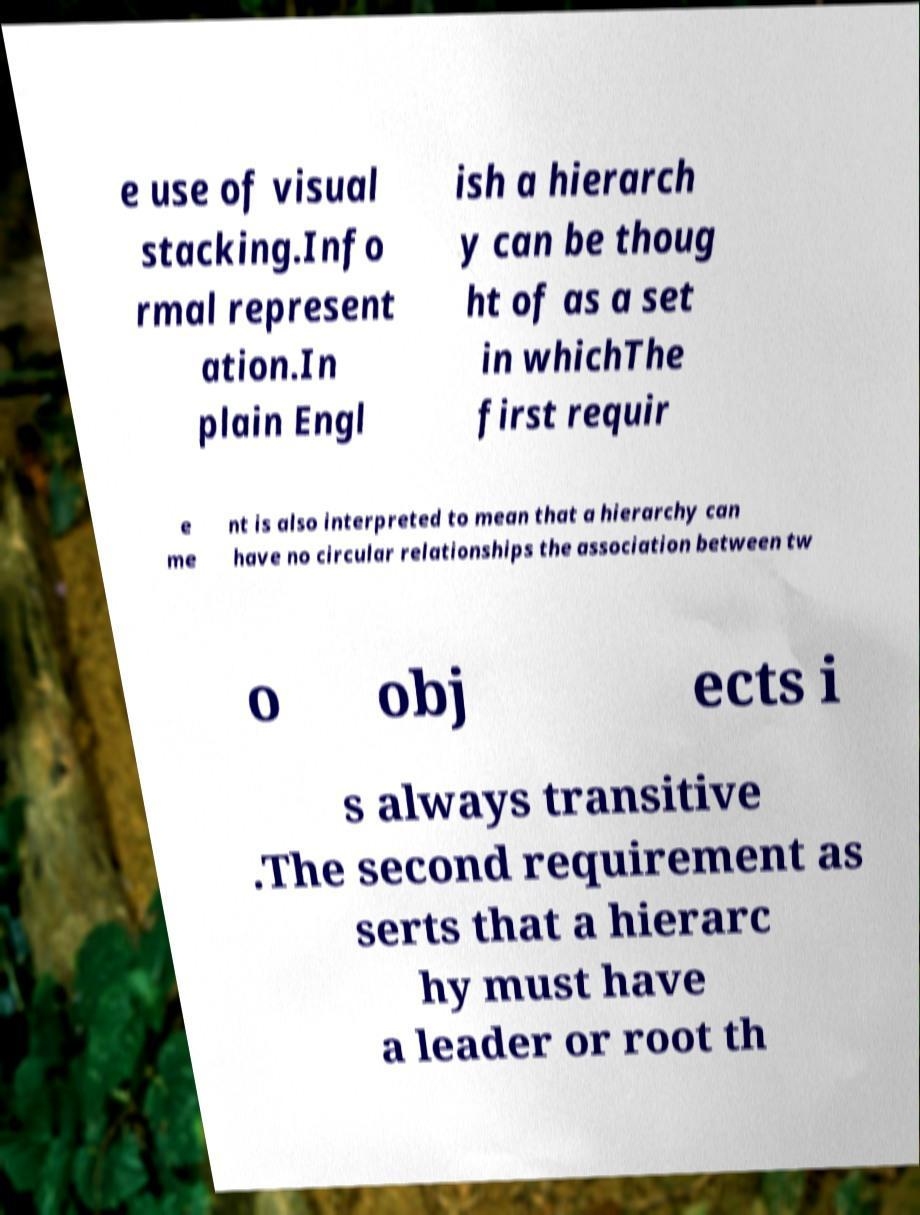What messages or text are displayed in this image? I need them in a readable, typed format. e use of visual stacking.Info rmal represent ation.In plain Engl ish a hierarch y can be thoug ht of as a set in whichThe first requir e me nt is also interpreted to mean that a hierarchy can have no circular relationships the association between tw o obj ects i s always transitive .The second requirement as serts that a hierarc hy must have a leader or root th 